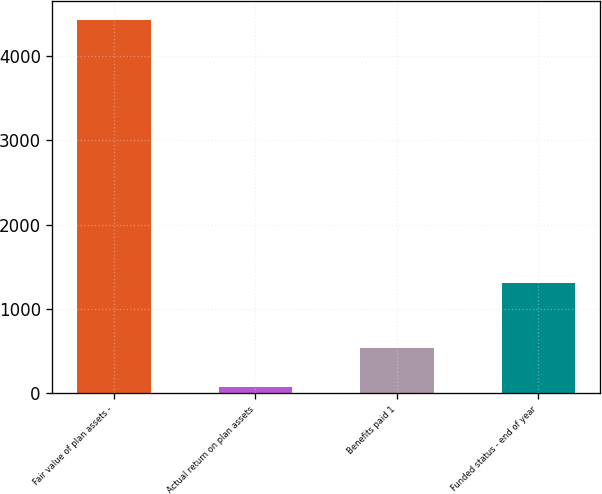<chart> <loc_0><loc_0><loc_500><loc_500><bar_chart><fcel>Fair value of plan assets -<fcel>Actual return on plan assets<fcel>Benefits paid 1<fcel>Funded status - end of year<nl><fcel>4430<fcel>72<fcel>535.5<fcel>1304<nl></chart> 